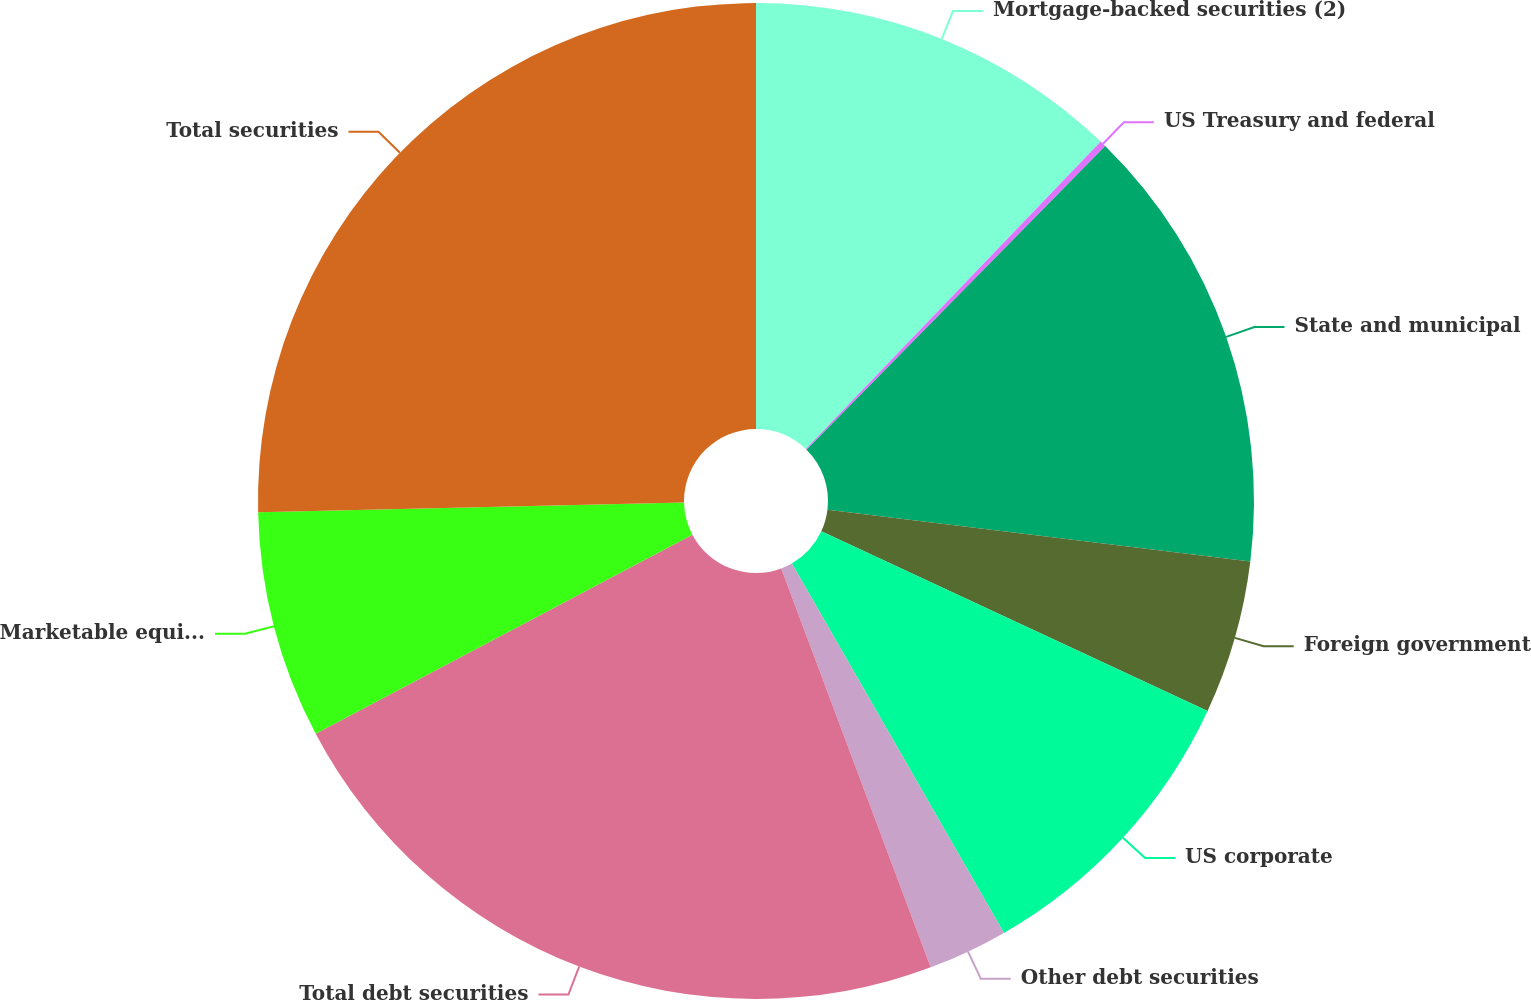Convert chart to OTSL. <chart><loc_0><loc_0><loc_500><loc_500><pie_chart><fcel>Mortgage-backed securities (2)<fcel>US Treasury and federal<fcel>State and municipal<fcel>Foreign government<fcel>US corporate<fcel>Other debt securities<fcel>Total debt securities<fcel>Marketable equity securities<fcel>Total securities<nl><fcel>12.17%<fcel>0.2%<fcel>14.57%<fcel>4.99%<fcel>9.78%<fcel>2.59%<fcel>22.97%<fcel>7.38%<fcel>25.36%<nl></chart> 